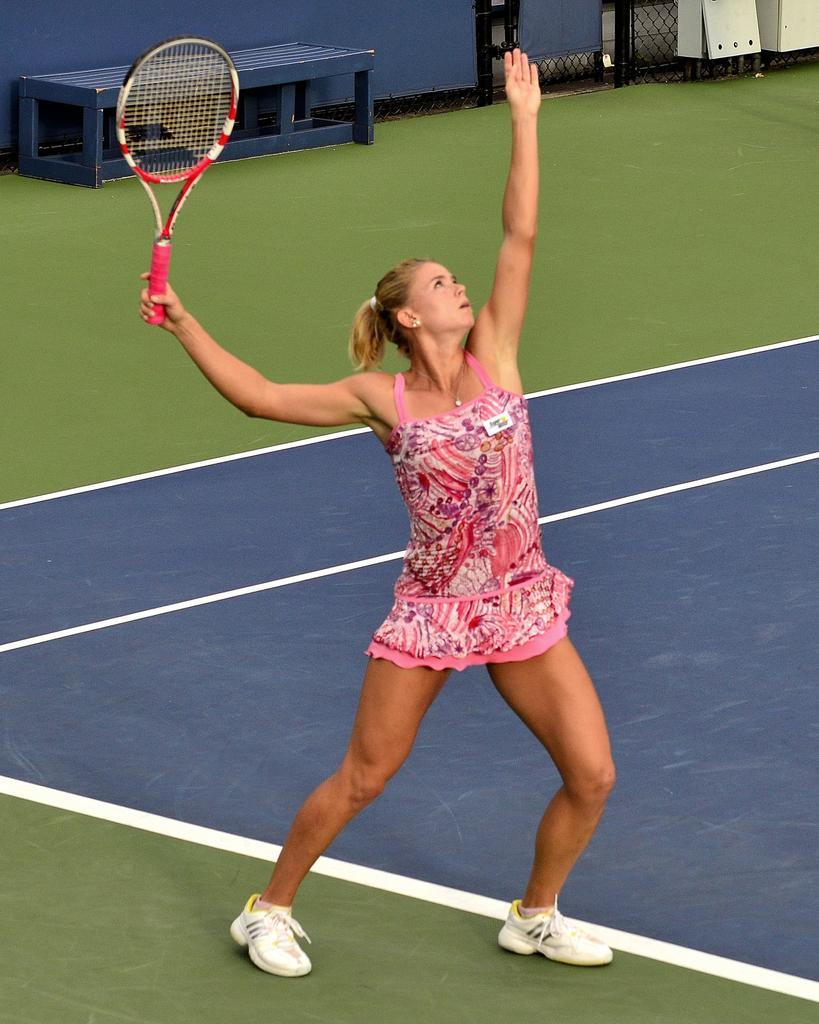How would you summarize this image in a sentence or two? In this picture we can see a woman, she is holding a bat in her hand, in the background we can see a bench. 